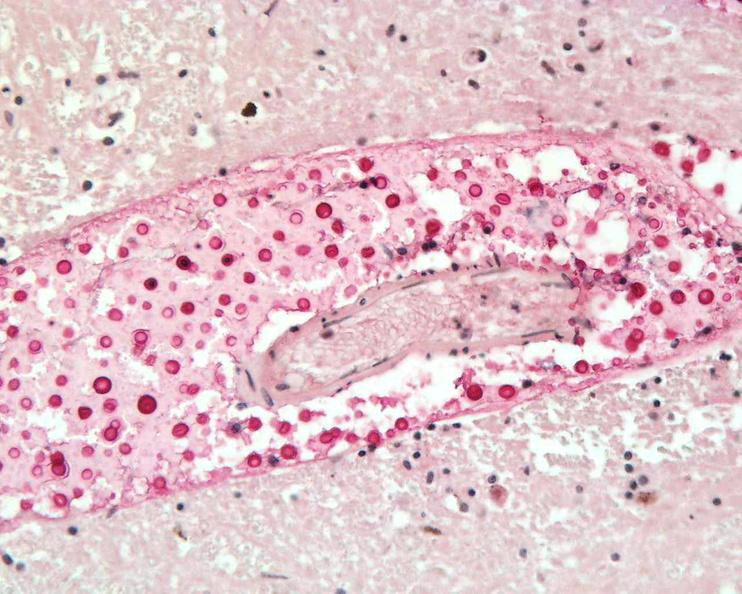what is present?
Answer the question using a single word or phrase. Nervous 